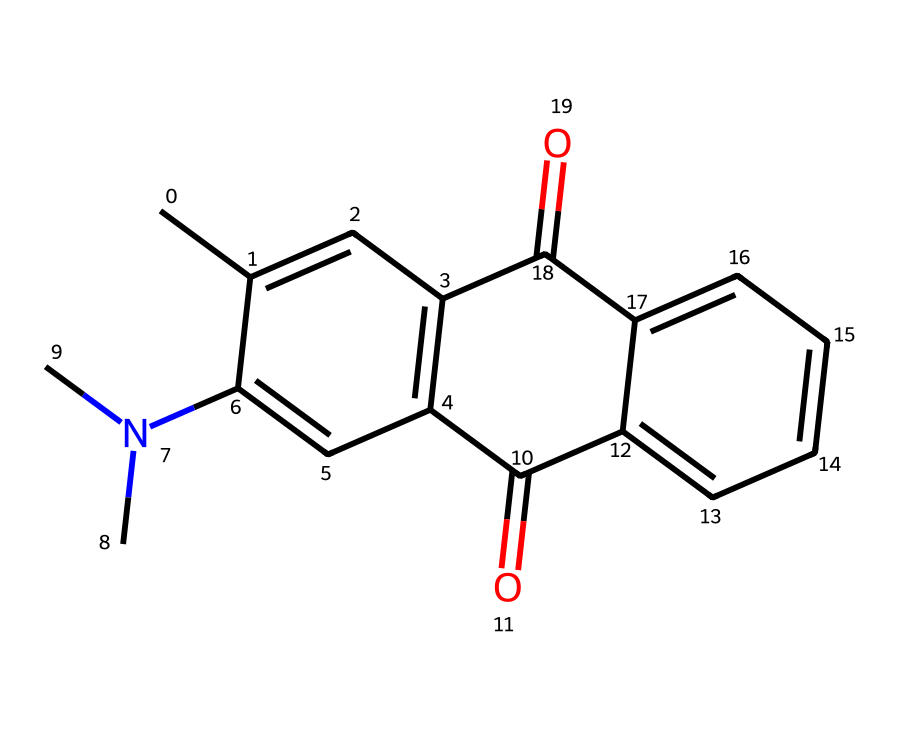What is the primary functional group present in this dye? The structure shows carbon atoms with an attached nitrogen (indicated by the N symbol) and carbonyl groups (C=O), identifying it as an amide group.
Answer: amide How many conjugated double bonds are present in this dye's structure? By analyzing the SMILES string, we can count the number of double bonds in the aromatic rings and between carbon atoms, leading to a total of 4 conjugated double bonds.
Answer: 4 What color does this fluorescent dye typically emit under UV light? The chemical structure suggests the presence of conjugated systems, like those in many dyes used in highlighters, which typically emit bright yellow to green colors under UV light because of the fluorescence.
Answer: yellow-green What type of molecular structure does this dye represent? The presence of the indicated rings, conjugated systems, and substituents suggests a polycyclic aromatic compound structure, characteristic of many dyes.
Answer: polycyclic aromatic How many nitrogen atoms are in the molecular structure? Counting the nitrogen symbols (N) in the SMILES representation, we see that there is one nitrogen atom present in the molecule.
Answer: 1 What is the molecular weight of this dye approximately, given its structure? By calculating the molecular weight from the number of each type of atom (C, H, N, O) using common atomic weights, we find the total to be approximately 265 g/mol.
Answer: 265 g/mol What is the significance of the carbonyl groups in this dye? The carbonyl groups (C=O) in the structure are important for the dye's ability to absorb light and contribute to its fluorescence properties by stabilizing excited states.
Answer: light absorption 